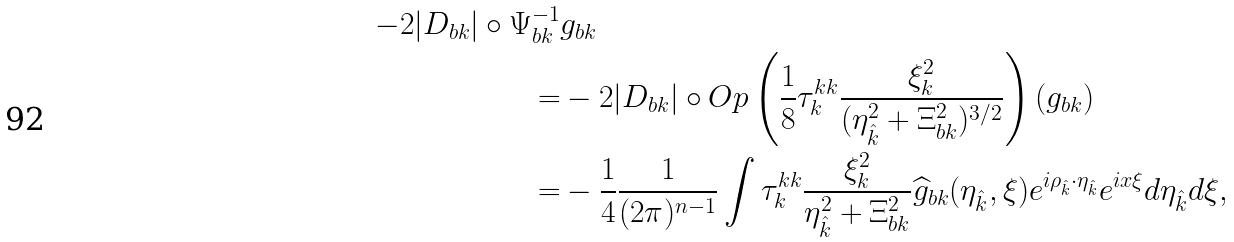Convert formula to latex. <formula><loc_0><loc_0><loc_500><loc_500>- 2 | D _ { b k } | \circ \Psi ^ { - 1 } _ { b k } & g _ { b k } \\ = & - 2 | D _ { b k } | \circ O p \left ( \frac { 1 } { 8 } \tau _ { k } ^ { k k } \frac { \xi _ { k } ^ { 2 } } { ( \eta _ { \hat { k } } ^ { 2 } + \Xi _ { b k } ^ { 2 } ) ^ { 3 / 2 } } \right ) \left ( g _ { b k } \right ) \\ = & - \frac { 1 } { 4 } \frac { 1 } { ( 2 \pi ) ^ { n - 1 } } \int \tau _ { k } ^ { k k } \frac { \xi _ { k } ^ { 2 } } { \eta _ { \hat { k } } ^ { 2 } + \Xi _ { b k } ^ { 2 } } \widehat { g } _ { b k } ( \eta _ { \hat { k } } , \xi ) e ^ { i \rho _ { \hat { k } } \cdot \eta _ { \hat { k } } } e ^ { i x \xi } d \eta _ { \hat { k } } d \xi ,</formula> 